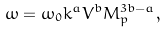Convert formula to latex. <formula><loc_0><loc_0><loc_500><loc_500>\omega = \omega _ { 0 } k ^ { a } V ^ { b } M _ { p } ^ { 3 b - a } ,</formula> 